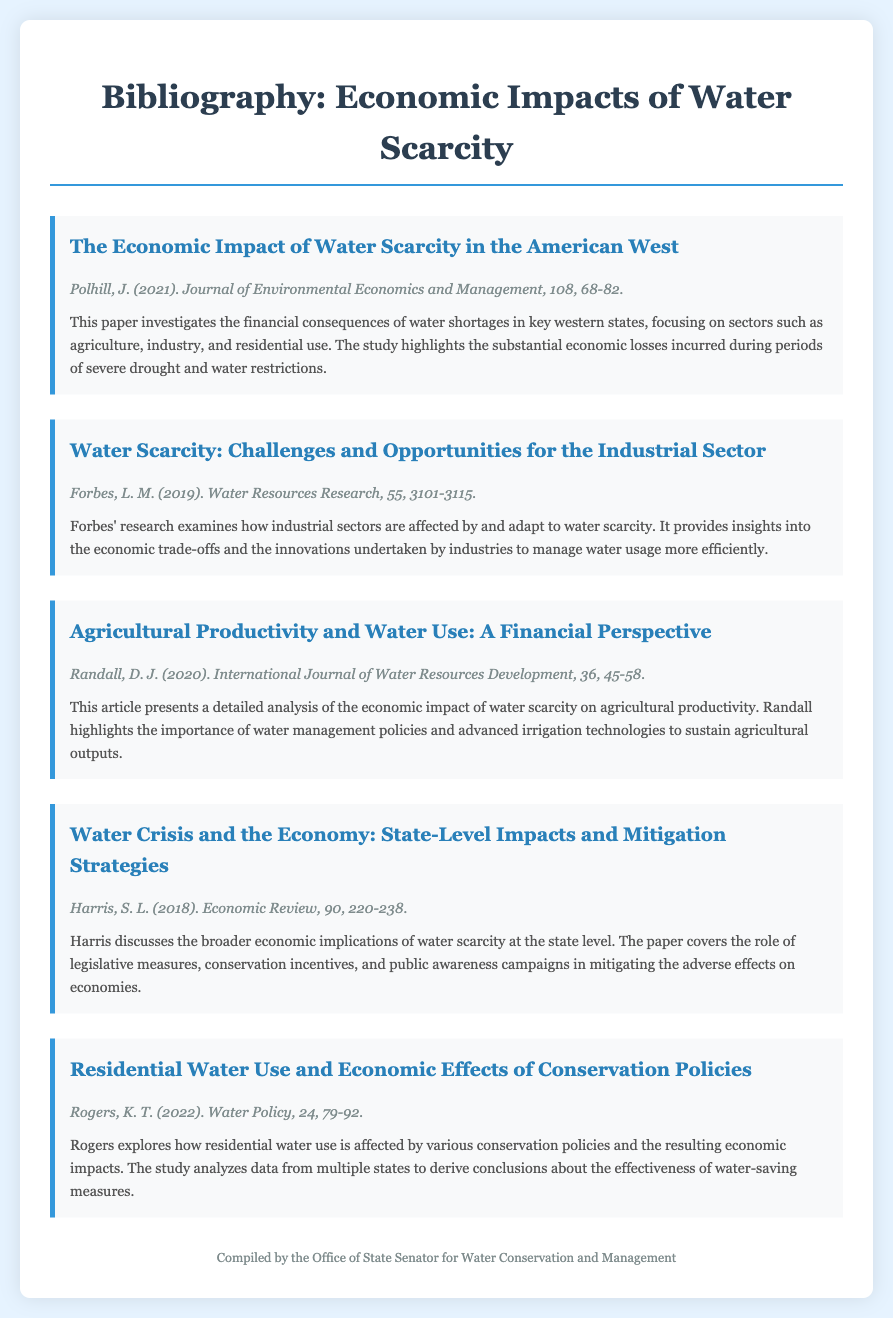What is the title of the first entry? The title of the first entry is the name of the paper presented in the bibliography.
Answer: The Economic Impact of Water Scarcity in the American West Who is the author of the paper published in 2019? The author is mentioned in the metadata of the respective entry.
Answer: L. M. Forbes In which journal was the 2020 article published? The journal's name is included in the citation of the entry.
Answer: International Journal of Water Resources Development What year was the paper "Water Crisis and the Economy" published? The publication year is stated in the meta section of the entry.
Answer: 2018 How many pages does the paper by Randall cover? The page range is specified in the citation of the entry.
Answer: 45-58 What sector does Forbes focus on in their research regarding water scarcity? The paper's description highlights the primary focus of the study conducted by Forbes.
Answer: Industrial sector Which entry discusses residential water use? This question aims to identify the entry relevant to residential water concerns mentioned in the bibliography.
Answer: Residential Water Use and Economic Effects of Conservation Policies What is the primary theme of Harris's paper? The theme refers to the main topic covered in Susan Harris's research about water scarcity.
Answer: Economic implications at the state level 